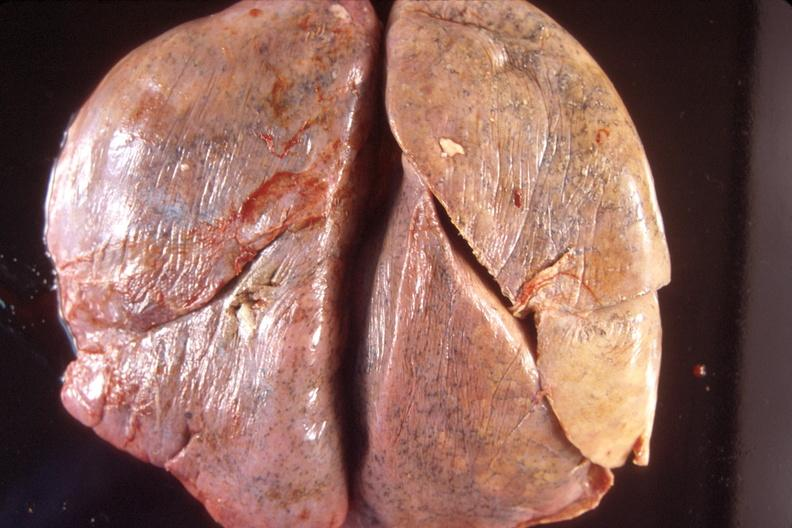s respiratory present?
Answer the question using a single word or phrase. Yes 